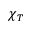Convert formula to latex. <formula><loc_0><loc_0><loc_500><loc_500>\chi _ { T }</formula> 